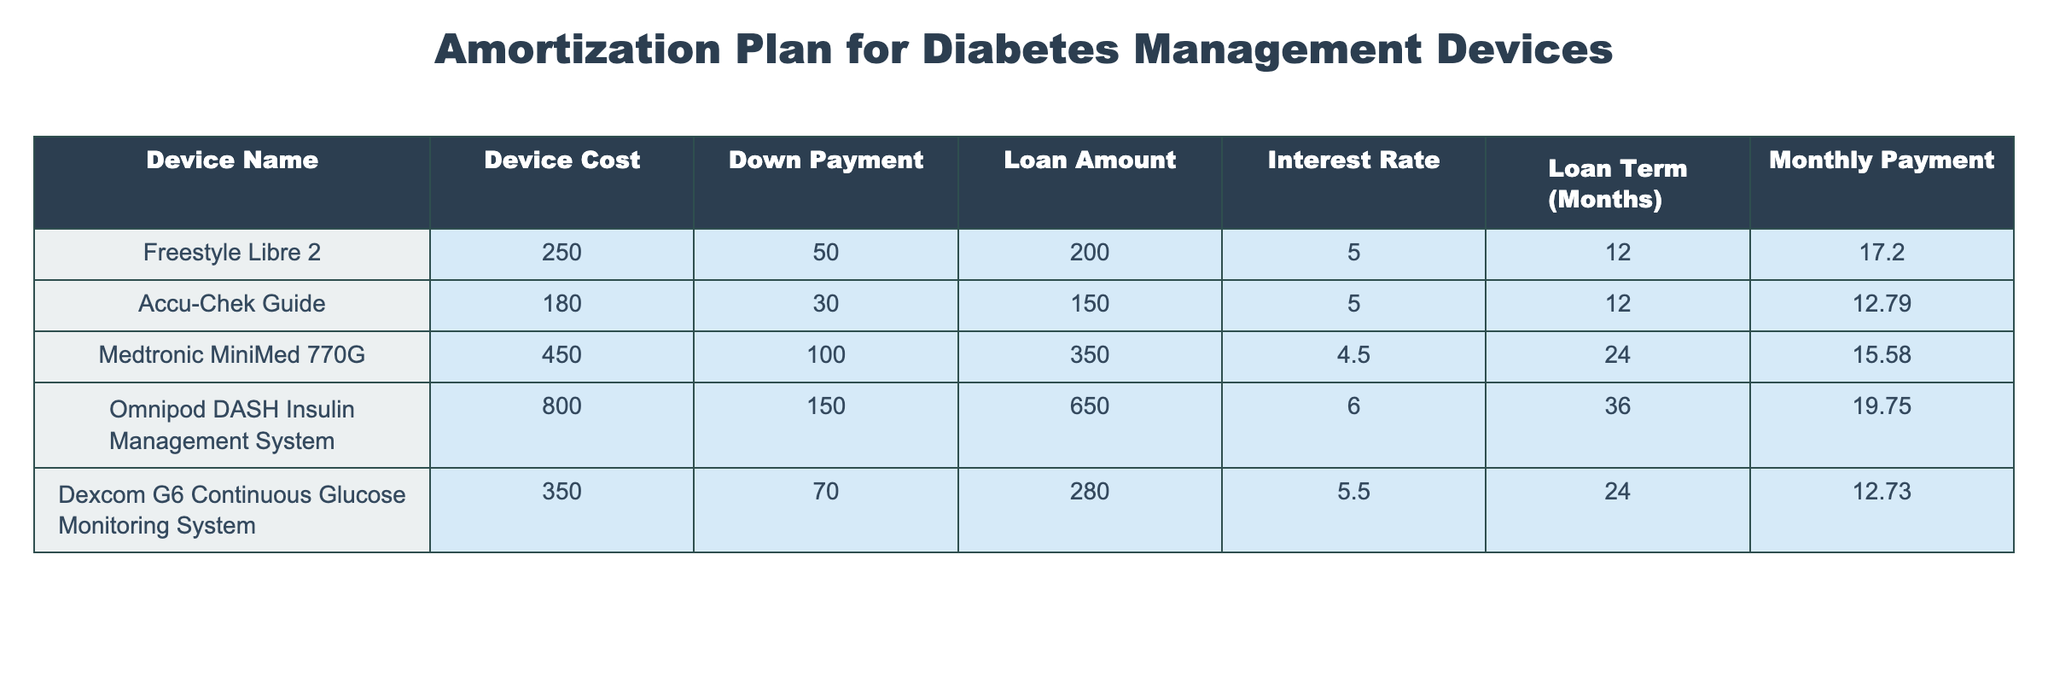What is the device cost of the Freestyle Libre 2? The table shows the device cost for each diabetes management device. Looking at the row for Freestyle Libre 2, the device cost is listed as 250.
Answer: 250 What is the monthly payment for the Accu-Chek Guide? Referring to the row for Accu-Chek Guide in the table, the monthly payment is provided, which is 12.79.
Answer: 12.79 Which device has the highest loan amount? To find this, we can compare the loan amounts listed for each device. The Omnipod DASH Insulin Management System has a loan amount of 650, which is higher than the others.
Answer: Omnipod DASH Insulin Management System What is the total loan amount for all the devices? We will sum the loan amounts from each device: 200 (Freestyle Libre 2) + 150 (Accu-Chek Guide) + 350 (Medtronic MiniMed 770G) + 650 (Omnipod DASH) + 280 (Dexcom G6) = 1,580.
Answer: 1580 Is the interest rate for the Medtronic MiniMed 770G lower than 5%? The interest rate for the Medtronic MiniMed 770G is listed as 4.5%, which is less than 5%. Therefore, the answer is yes.
Answer: Yes What is the average monthly payment for the devices listed? To find the average, we need to add the monthly payments: 17.20 (Freestyle Libre 2) + 12.79 (Accu-Chek Guide) + 15.58 (Medtronic MiniMed 770G) + 19.75 (Omnipod DASH) + 12.73 (Dexcom G6) = 78.05. Next, we divide this total by the number of devices, which is 5. So, 78.05 / 5 = 15.61.
Answer: 15.61 How many devices have a loan term longer than 24 months? From the table, we examine the loan terms for each device. The Medtronic MiniMed 770G has a loan term of 24 months, and the Omnipod DASH has a loan term of 36 months. The count of devices with loan terms longer than 24 months is 1 (Omnipod DASH).
Answer: 1 What is the difference in device cost between the most expensive and least expensive device? The most expensive device is the Omnipod DASH at a cost of 800, and the least expensive is the Accu-Chek Guide at a cost of 180. Now, we calculate the difference: 800 - 180 = 620.
Answer: 620 Does the device with the lowest monthly payment also have the lowest device cost? The lowest monthly payment is 12.73 for the Dexcom G6, and the lowest device cost is 180 for the Accu-Chek Guide. Since Dexcom G6 costs 350, the answer is no.
Answer: No 